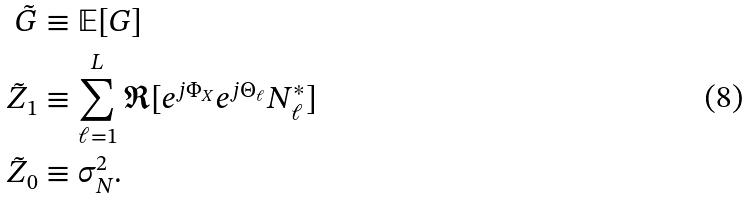Convert formula to latex. <formula><loc_0><loc_0><loc_500><loc_500>\tilde { G } & \equiv \mathbb { E } [ G ] \\ \tilde { Z } _ { 1 } & \equiv \sum _ { \ell = 1 } ^ { L } \Re [ e ^ { j \Phi _ { X } } e ^ { j \Theta _ { \ell } } N _ { \ell } ^ { * } ] \\ \tilde { Z } _ { 0 } & \equiv \sigma _ { N } ^ { 2 } .</formula> 